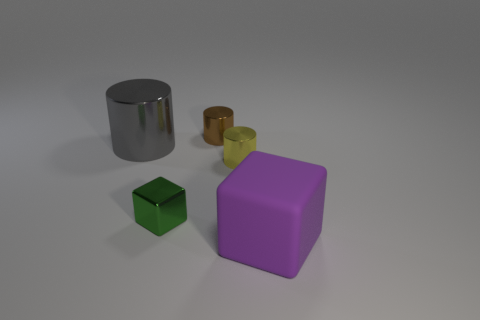How many cylinders are either matte things or small brown things?
Your answer should be very brief. 1. Are there any gray metal cylinders that are to the right of the object behind the large thing that is behind the yellow cylinder?
Give a very brief answer. No. What color is the other tiny metallic object that is the same shape as the tiny yellow object?
Offer a very short reply. Brown. What number of green things are either metal things or tiny things?
Your answer should be compact. 1. What material is the big object to the right of the big object that is behind the rubber object made of?
Your answer should be very brief. Rubber. Is the shape of the small green shiny object the same as the matte object?
Your answer should be compact. Yes. What is the color of the cylinder that is the same size as the rubber block?
Provide a succinct answer. Gray. Are any metallic blocks visible?
Give a very brief answer. Yes. Is the block that is behind the large rubber thing made of the same material as the tiny brown cylinder?
Provide a short and direct response. Yes. How many balls are the same size as the brown cylinder?
Your response must be concise. 0. 